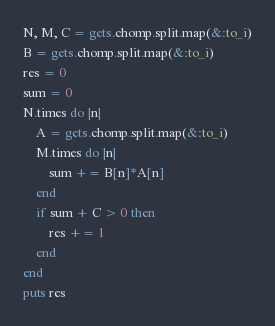Convert code to text. <code><loc_0><loc_0><loc_500><loc_500><_Ruby_>N, M, C = gets.chomp.split.map(&:to_i)
B = gets.chomp.split.map(&:to_i)
res = 0
sum = 0
N.times do |n|
    A = gets.chomp.split.map(&:to_i)
    M.times do |n|
        sum += B[n]*A[n]
    end
    if sum + C > 0 then
        res += 1
    end
end
puts res</code> 